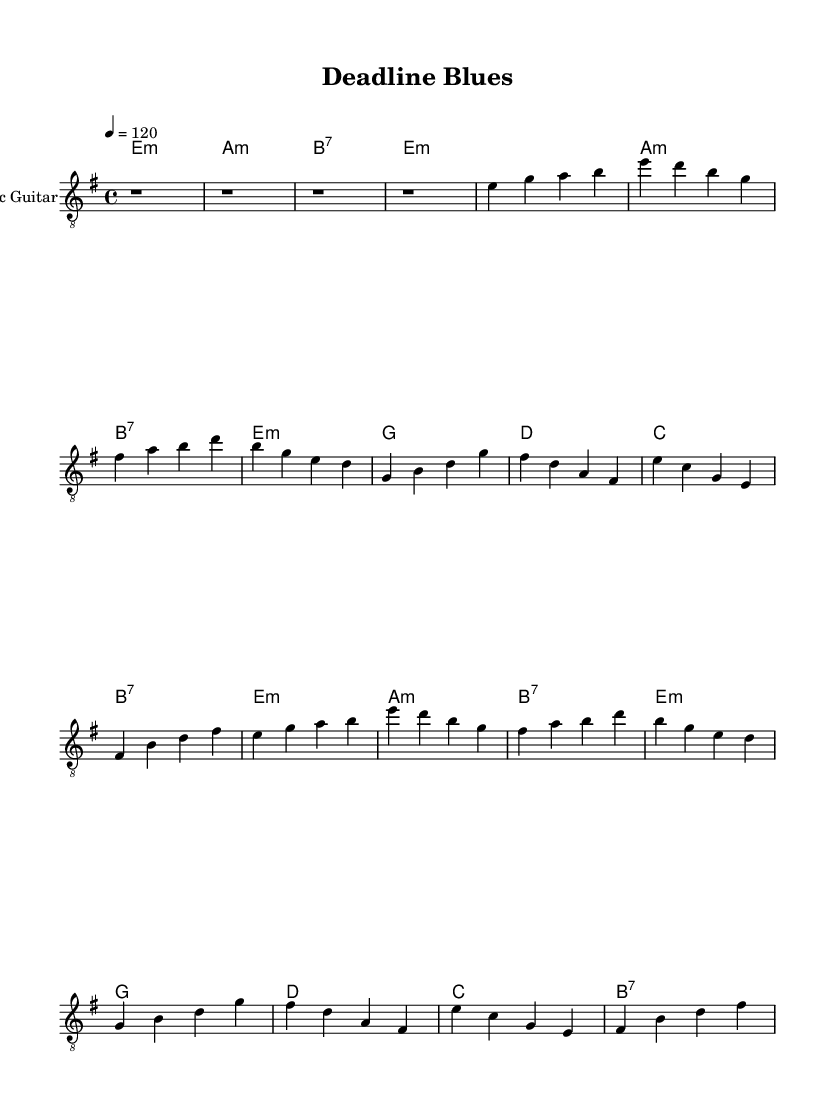What is the key signature of this music? The key signature is E minor, indicated by the presence of one sharp (F#) in the key signature at the beginning of the sheet music.
Answer: E minor What is the time signature of this music? The time signature shown in the music is 4/4, which can be found directly beneath the clef symbol at the beginning of the score.
Answer: 4/4 What is the tempo marking for this music? The tempo marking is a quarter note equals 120 beats per minute, indicated as "4 = 120" near the top of the sheet music.
Answer: 120 How many verses are present in the music? The score includes two verses, as indicated by the structure of the music which labels the sections with two repetitions of the verses in the overall layout.
Answer: 2 What type of chords are used in the chorus section? The chorus section utilizes major chords and a seventh chord, specifically G major, D major, C major, and B7, as indicated in the chord names beneath the respective sections of the score.
Answer: Major and seventh chords What is the first chord in the intro of this music? The first chord in the intro is an E minor chord, as indicated in the chord names section where it specifies the chord changes starting from E minor.
Answer: E minor 